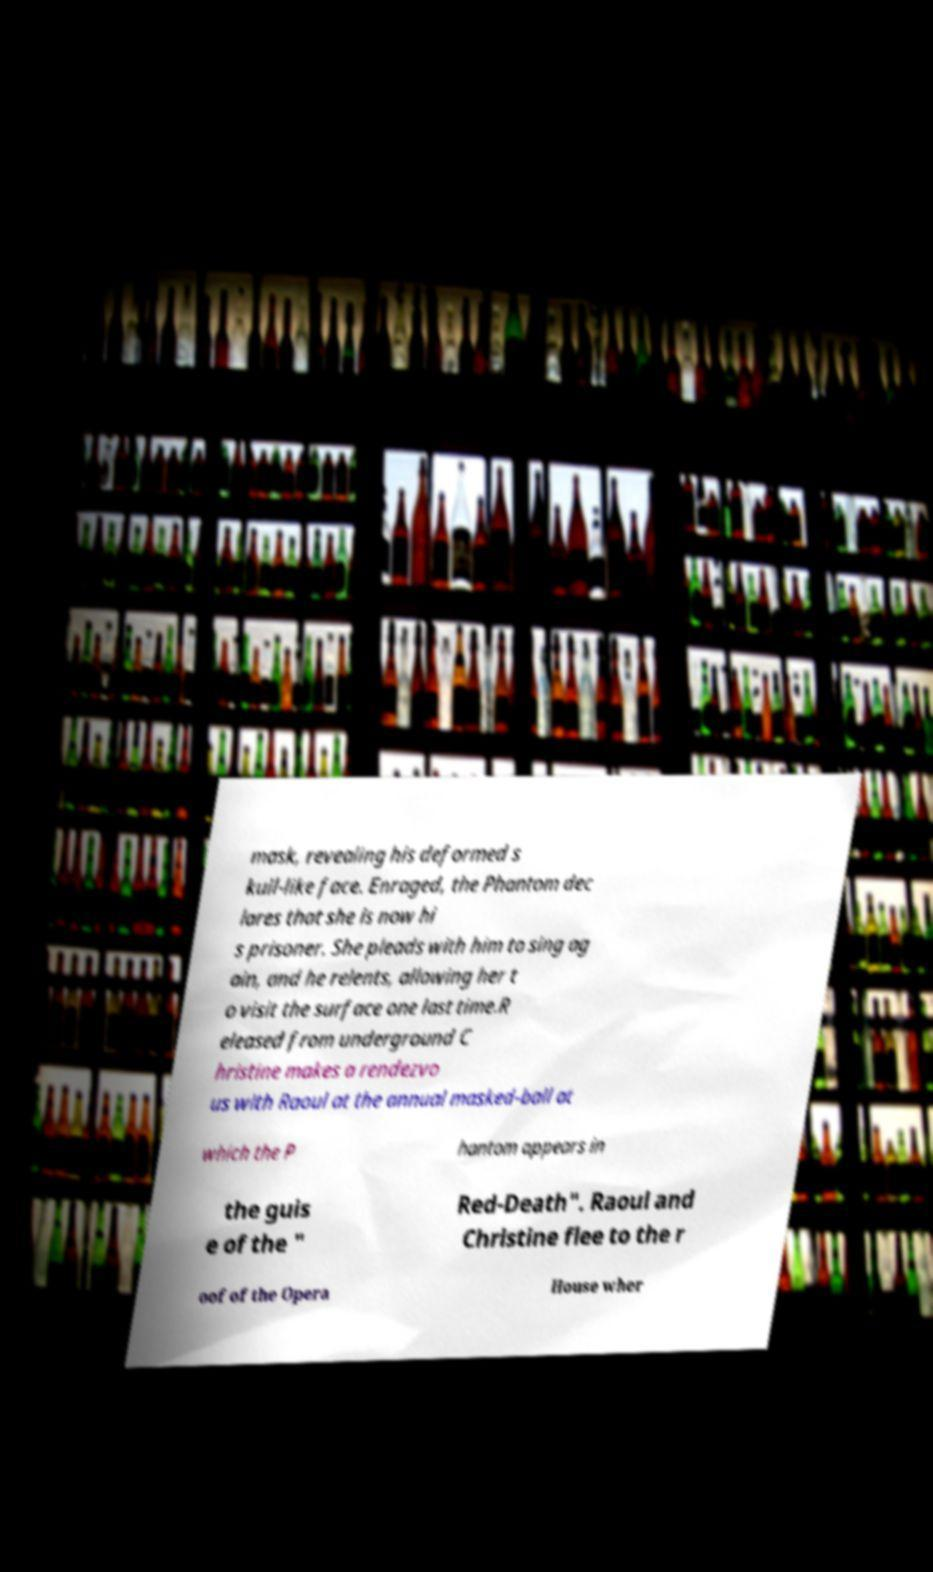Can you accurately transcribe the text from the provided image for me? mask, revealing his deformed s kull-like face. Enraged, the Phantom dec lares that she is now hi s prisoner. She pleads with him to sing ag ain, and he relents, allowing her t o visit the surface one last time.R eleased from underground C hristine makes a rendezvo us with Raoul at the annual masked-ball at which the P hantom appears in the guis e of the " Red-Death". Raoul and Christine flee to the r oof of the Opera House wher 